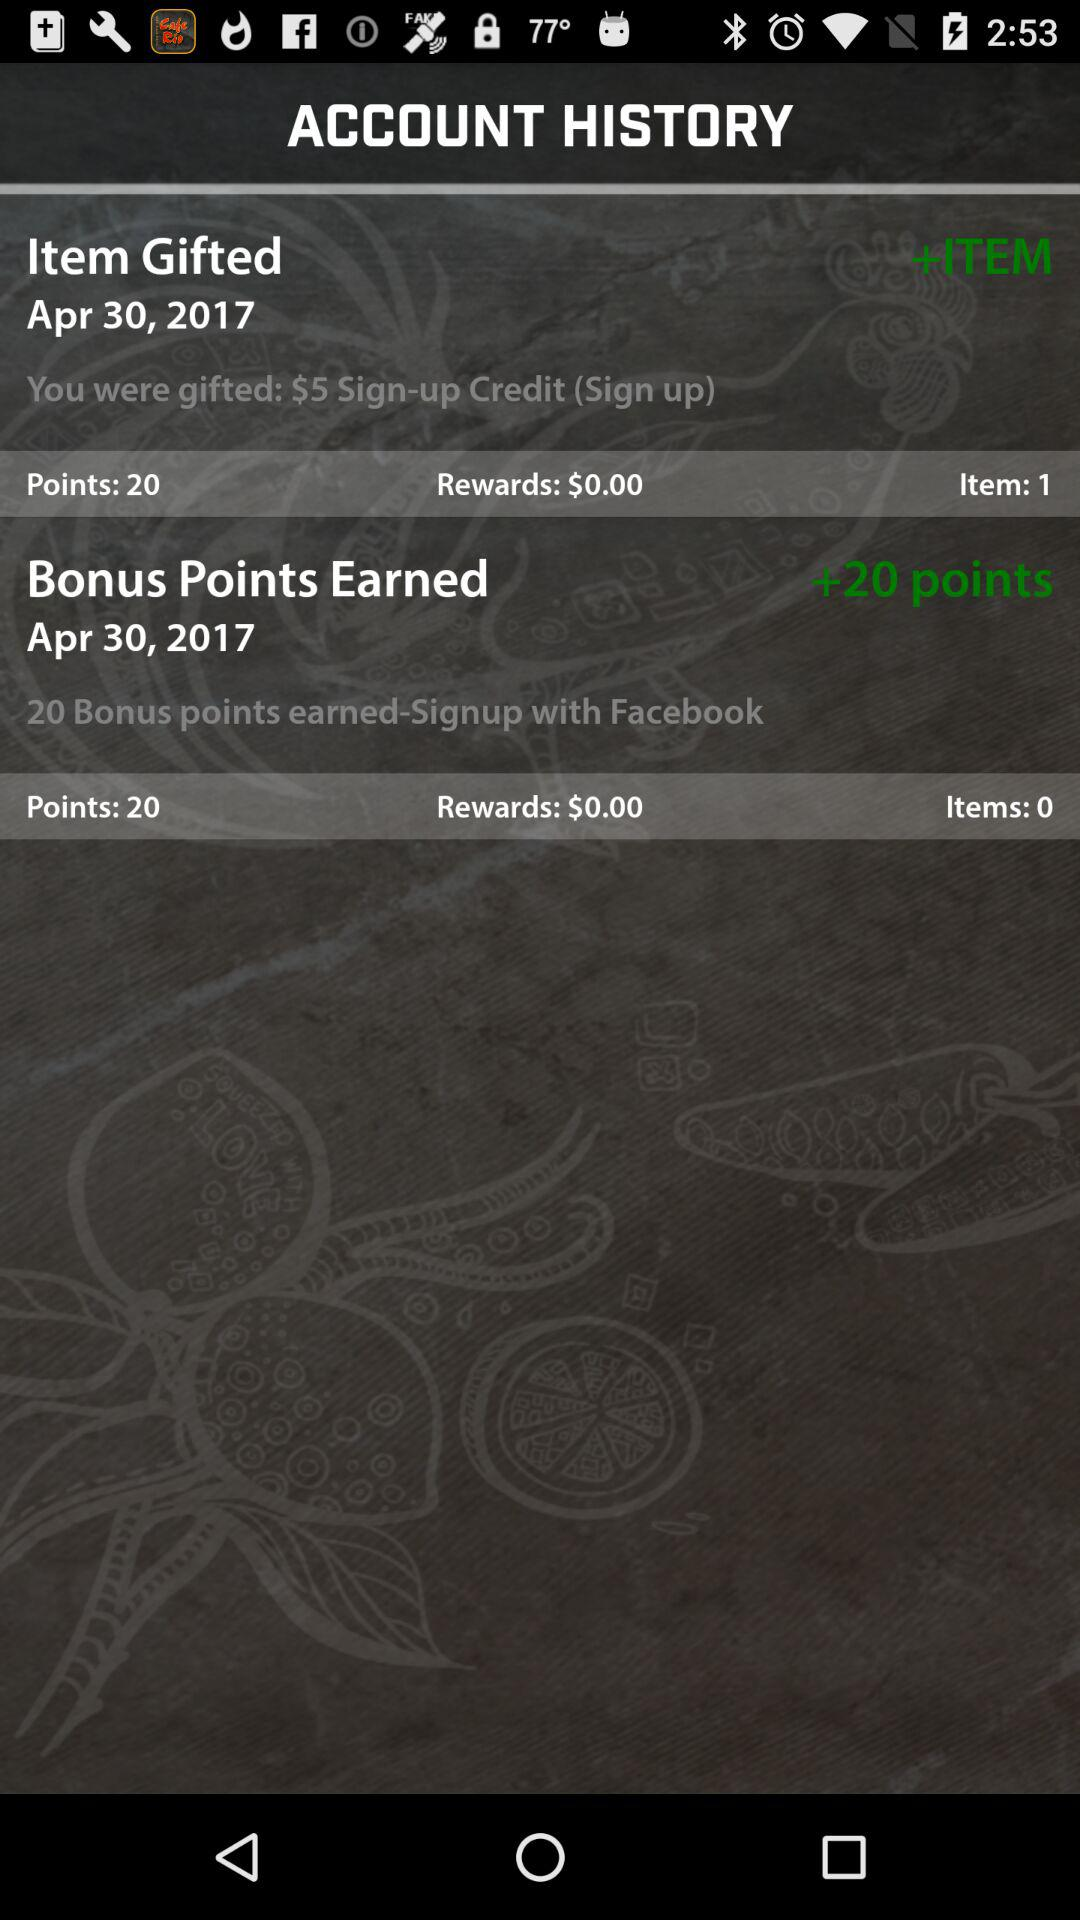How many points are in the item gifted? There are 20 points in the item gifted. 